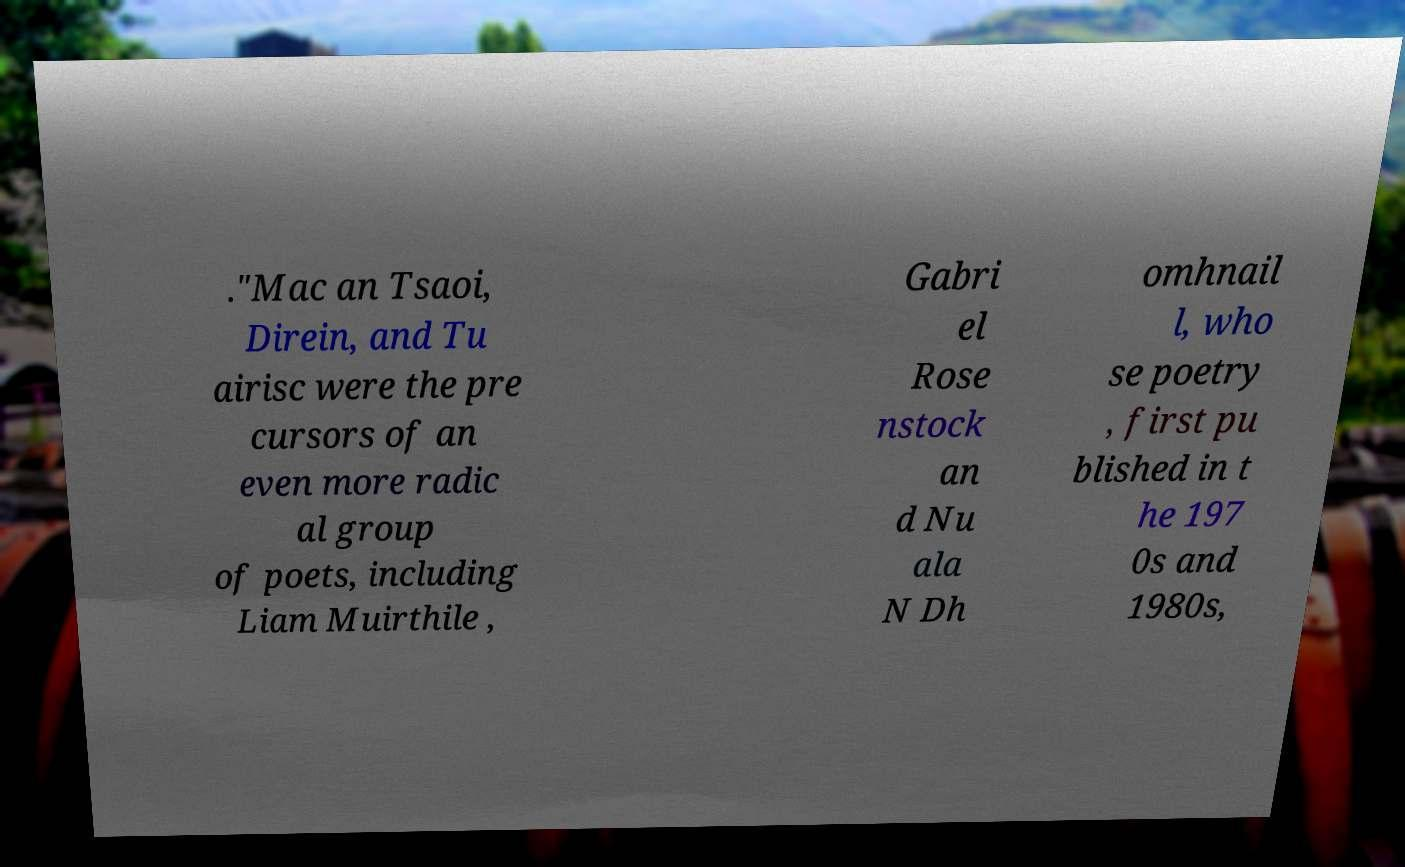Please read and relay the text visible in this image. What does it say? ."Mac an Tsaoi, Direin, and Tu airisc were the pre cursors of an even more radic al group of poets, including Liam Muirthile , Gabri el Rose nstock an d Nu ala N Dh omhnail l, who se poetry , first pu blished in t he 197 0s and 1980s, 